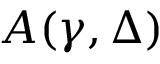Convert formula to latex. <formula><loc_0><loc_0><loc_500><loc_500>A ( \gamma , \Delta )</formula> 